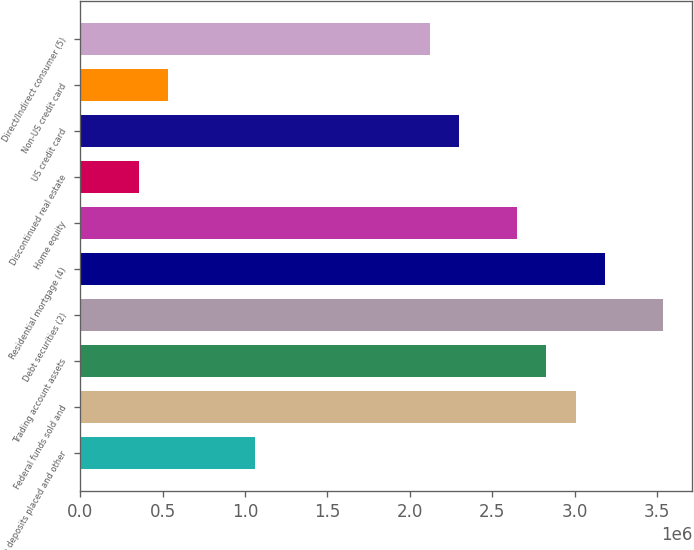Convert chart. <chart><loc_0><loc_0><loc_500><loc_500><bar_chart><fcel>Time deposits placed and other<fcel>Federal funds sold and<fcel>Trading account assets<fcel>Debt securities (2)<fcel>Residential mortgage (4)<fcel>Home equity<fcel>Discontinued real estate<fcel>US credit card<fcel>Non-US credit card<fcel>Direct/Indirect consumer (5)<nl><fcel>1.06138e+06<fcel>3.00488e+06<fcel>2.8282e+06<fcel>3.53492e+06<fcel>3.18156e+06<fcel>2.65151e+06<fcel>354650<fcel>2.29815e+06<fcel>531332<fcel>2.12147e+06<nl></chart> 